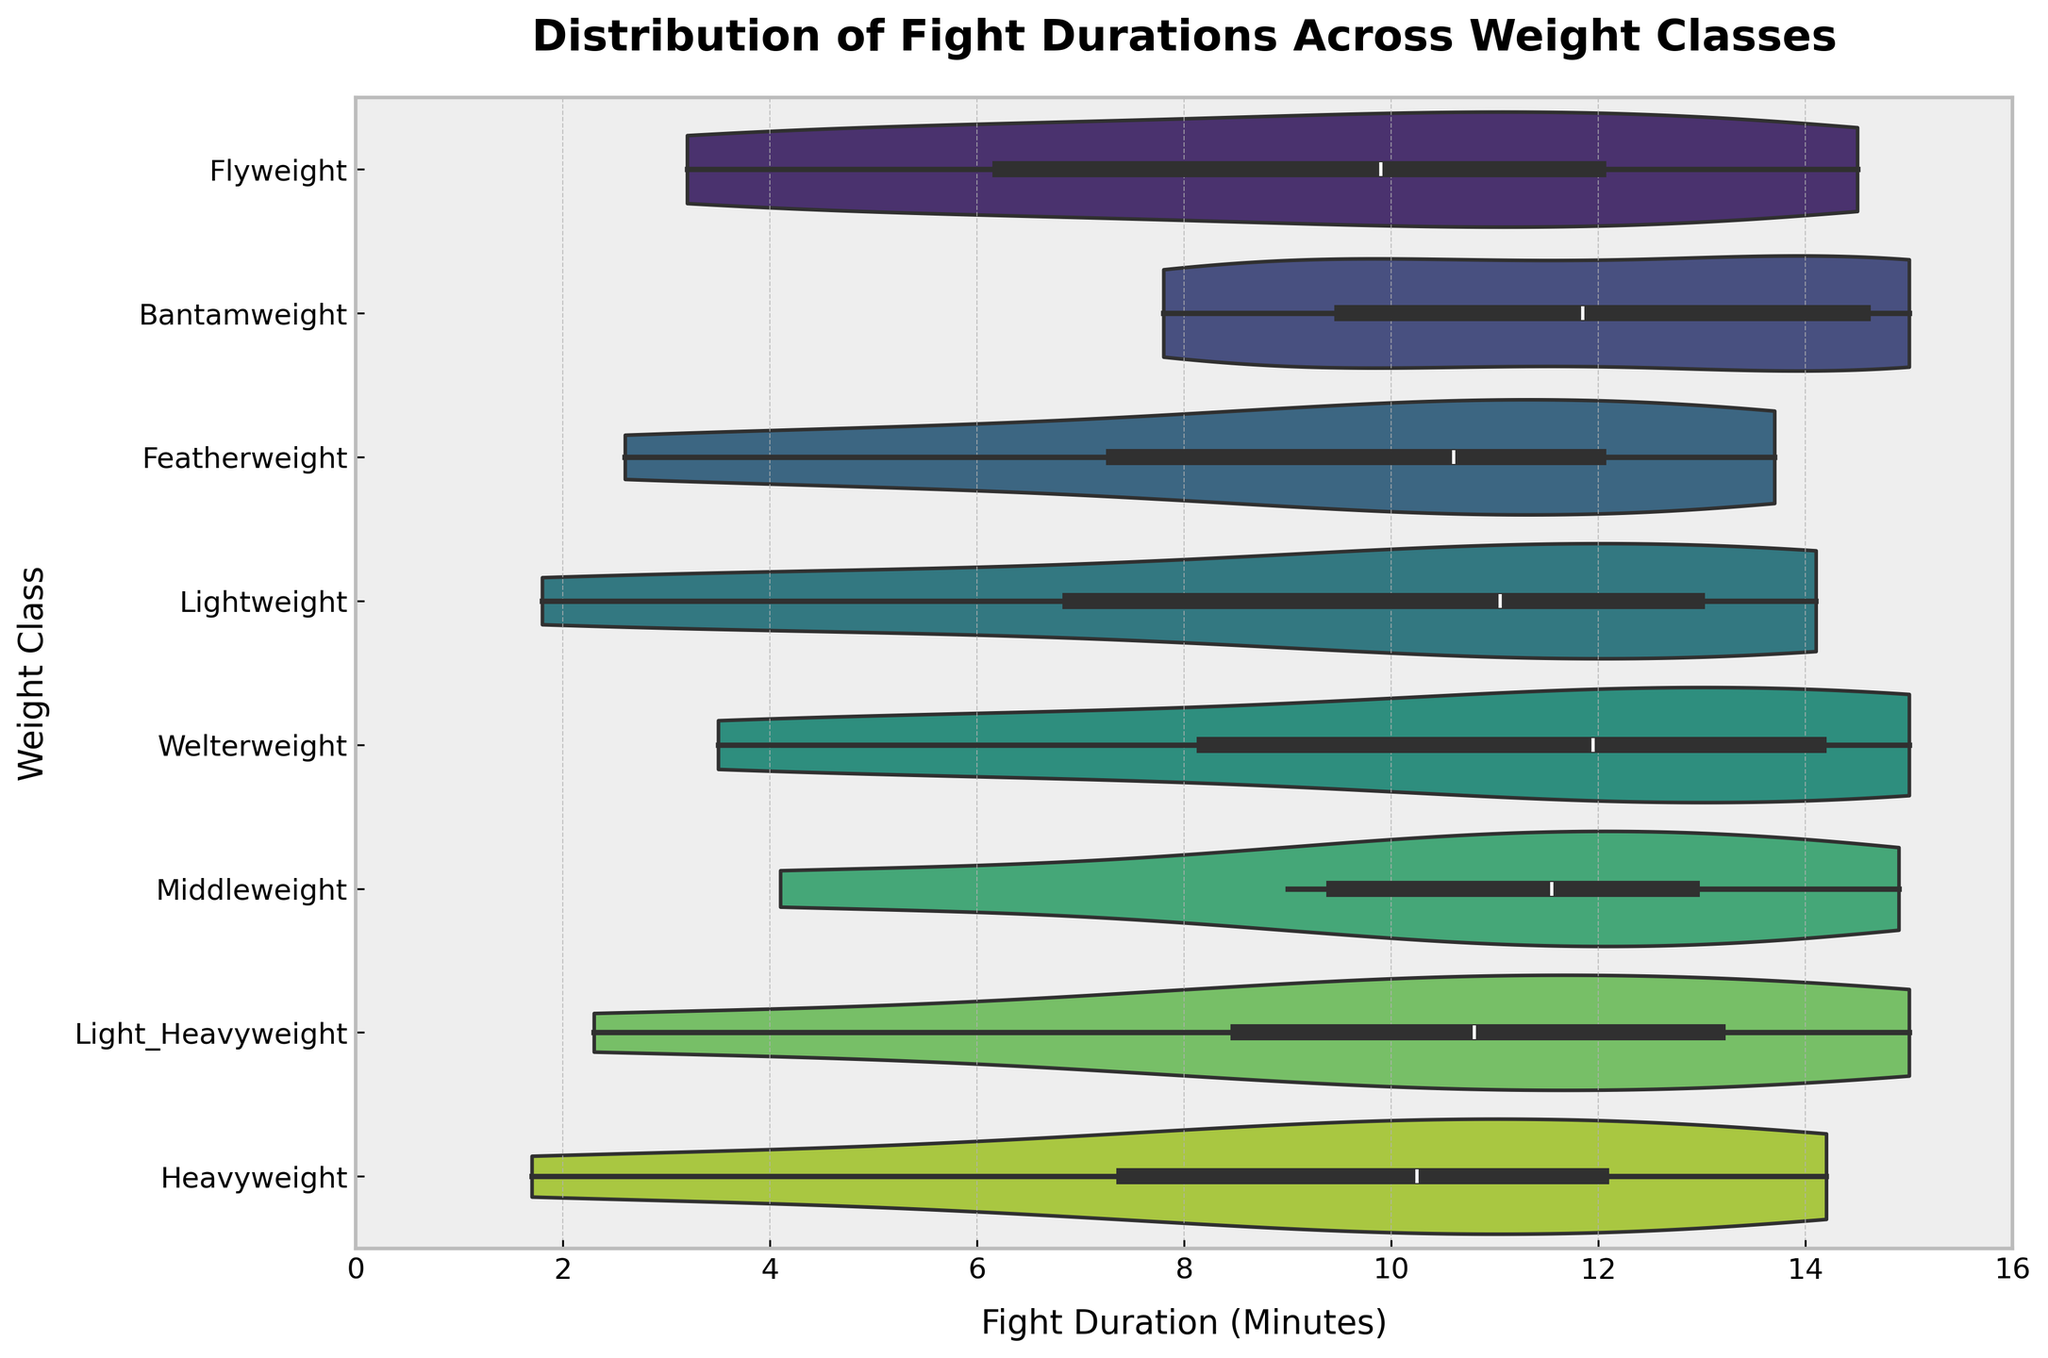How many weight classes are displayed in the chart? Count the distinct weight classes shown as labels on the y-axis of the violin plot.
Answer: 7 Which weight class has the longest fight duration? Identify the rightmost extent of the violin plot on the x-axis.
Answer: Welterweight What is the central tendency of the Flyweight fight durations? Observe the position of the thickest part (widest) of the Flyweight violin plot to gauge median or mode.
Answer: Around 12 minutes Which weight class has the shortest fight duration in its distribution? Find the leftmost extent of the violin plots across all weight classes.
Answer: Heavyweight Compare the range of fight durations between Middleweight and Lightweight classes. Which has a more extensive range? Look at the spread from the leftmost to rightmost points of the violin plots for both classes.
Answer: Lightweight Do Bantamweight durations show a peak closer to shorter or longer durations? Identify where the Bantamweight violin plot widens, indicating a concentration of fight durations.
Answer: Longer durations Among Lightweight and Featherweight, which weight class has a more evenly distributed fight duration? Evaluate the uniformity of the width of the violin plots across the duration range.
Answer: Featherweight How does the distribution shape of Light Heavyweight compare to Heavyweight fights? Look for the general shape (wider at the top or bottom, symmetrical or skewed) of each class's violin plot for differences.
Answer: Light Heavyweight is more evenly distributed, Heavyweight is skewed towards shorter durations Is there any weight class where the fight duration distribution is centralised around a single dominant mode? Look for any violin plots that are narrow or have a single wide section.
Answer: Featherweight Which weight classes exhibit fight durations extending to the maximum limit set on the x-axis? Identify any violin plots touching or closely approaching the upper limit of the x-axis at 16 minutes.
Answer: Bantamweight, Welterweight, Light Heavyweight 